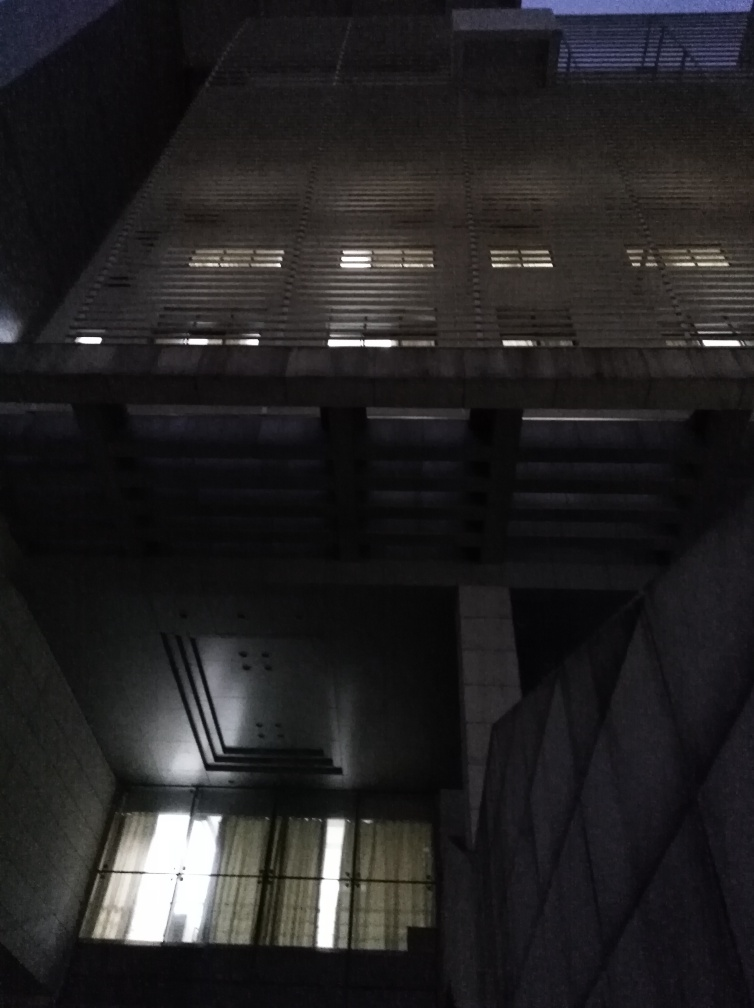What mood does the lighting in the image evoke? The lighting evokes a melancholic and mysterious mood. The dim lights shining through the windows contrast with the dark surroundings, emphasizing isolation and perhaps even intrigue. Could the time of day be inferred from the lighting? It suggests that the photo was taken either at dawn before the sunrise or at dusk after sunset, considering the sky's lack of natural light and the artificial lights that are on inside the building. 